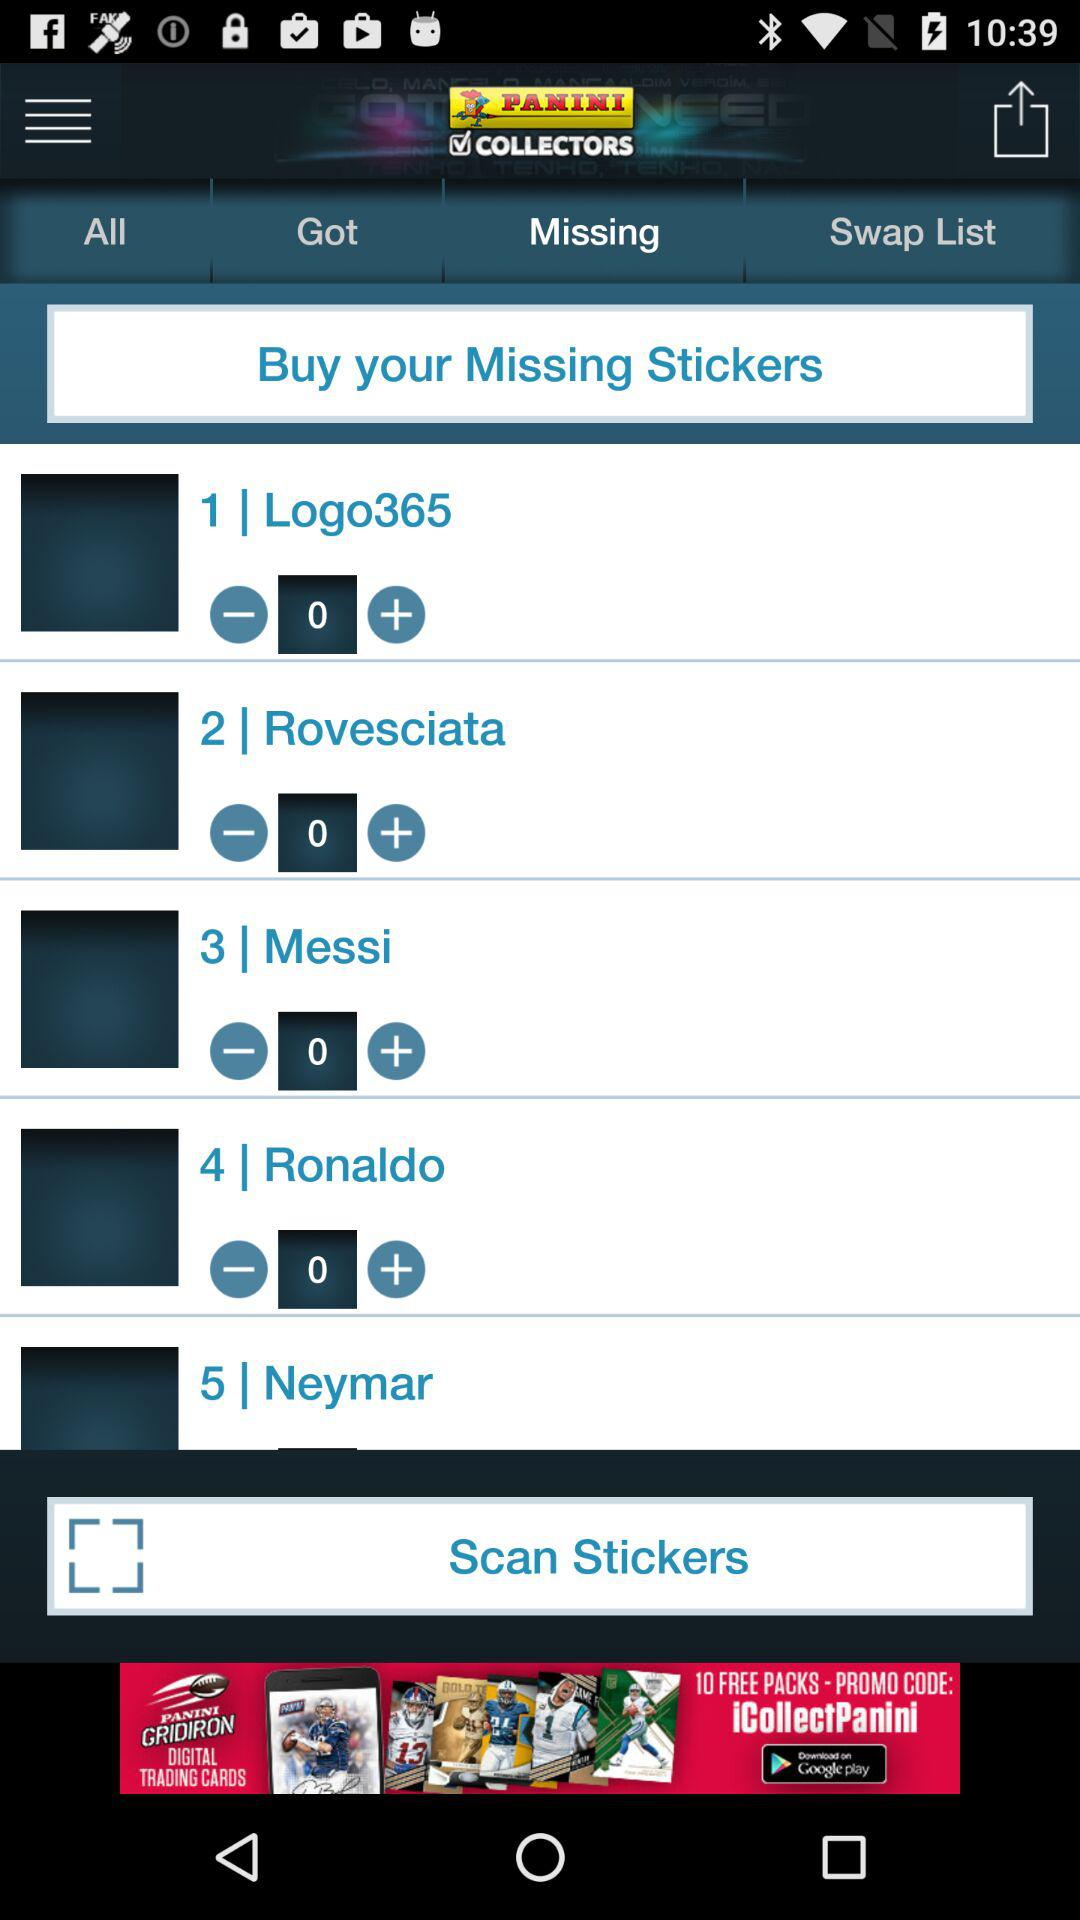Which sticker has the serial number 1? The sticker is "Logo365". 